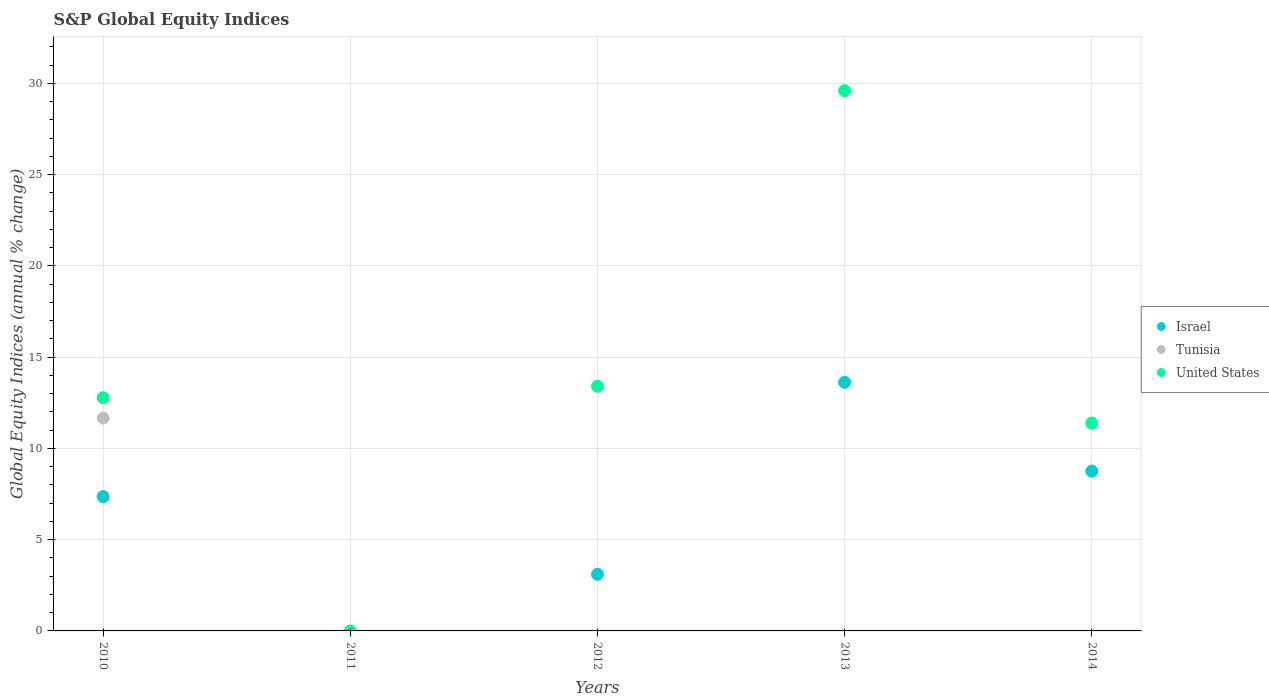How many different coloured dotlines are there?
Provide a succinct answer. 3. Is the number of dotlines equal to the number of legend labels?
Your answer should be very brief. No. Across all years, what is the maximum global equity indices in United States?
Your answer should be compact. 29.6. Across all years, what is the minimum global equity indices in United States?
Your answer should be compact. 0. In which year was the global equity indices in Israel maximum?
Provide a short and direct response. 2013. What is the total global equity indices in United States in the graph?
Make the answer very short. 67.18. What is the difference between the global equity indices in Israel in 2010 and that in 2013?
Offer a terse response. -6.26. What is the difference between the global equity indices in Israel in 2013 and the global equity indices in Tunisia in 2010?
Offer a terse response. 1.96. What is the average global equity indices in United States per year?
Provide a short and direct response. 13.44. In the year 2010, what is the difference between the global equity indices in Israel and global equity indices in United States?
Keep it short and to the point. -5.42. In how many years, is the global equity indices in Israel greater than 6 %?
Offer a terse response. 3. What is the ratio of the global equity indices in United States in 2010 to that in 2013?
Your answer should be compact. 0.43. Is the global equity indices in United States in 2010 less than that in 2012?
Offer a very short reply. Yes. What is the difference between the highest and the second highest global equity indices in Israel?
Make the answer very short. 4.87. What is the difference between the highest and the lowest global equity indices in United States?
Your answer should be compact. 29.6. Is the sum of the global equity indices in United States in 2010 and 2013 greater than the maximum global equity indices in Tunisia across all years?
Provide a short and direct response. Yes. Does the global equity indices in United States monotonically increase over the years?
Ensure brevity in your answer.  No. Is the global equity indices in Tunisia strictly greater than the global equity indices in Israel over the years?
Your response must be concise. No. Is the global equity indices in Israel strictly less than the global equity indices in Tunisia over the years?
Offer a terse response. No. Does the graph contain any zero values?
Make the answer very short. Yes. Does the graph contain grids?
Offer a very short reply. Yes. Where does the legend appear in the graph?
Your answer should be very brief. Center right. How many legend labels are there?
Provide a short and direct response. 3. How are the legend labels stacked?
Offer a terse response. Vertical. What is the title of the graph?
Your answer should be compact. S&P Global Equity Indices. Does "Other small states" appear as one of the legend labels in the graph?
Make the answer very short. No. What is the label or title of the X-axis?
Offer a very short reply. Years. What is the label or title of the Y-axis?
Your response must be concise. Global Equity Indices (annual % change). What is the Global Equity Indices (annual % change) in Israel in 2010?
Your answer should be compact. 7.36. What is the Global Equity Indices (annual % change) of Tunisia in 2010?
Ensure brevity in your answer.  11.66. What is the Global Equity Indices (annual % change) of United States in 2010?
Keep it short and to the point. 12.78. What is the Global Equity Indices (annual % change) in Tunisia in 2011?
Give a very brief answer. 0. What is the Global Equity Indices (annual % change) of United States in 2011?
Keep it short and to the point. 0. What is the Global Equity Indices (annual % change) of Israel in 2012?
Your answer should be compact. 3.1. What is the Global Equity Indices (annual % change) in United States in 2012?
Your response must be concise. 13.41. What is the Global Equity Indices (annual % change) in Israel in 2013?
Your answer should be very brief. 13.62. What is the Global Equity Indices (annual % change) of Tunisia in 2013?
Give a very brief answer. 0. What is the Global Equity Indices (annual % change) in United States in 2013?
Offer a terse response. 29.6. What is the Global Equity Indices (annual % change) of Israel in 2014?
Your answer should be very brief. 8.76. What is the Global Equity Indices (annual % change) in United States in 2014?
Your answer should be very brief. 11.39. Across all years, what is the maximum Global Equity Indices (annual % change) in Israel?
Offer a very short reply. 13.62. Across all years, what is the maximum Global Equity Indices (annual % change) in Tunisia?
Your response must be concise. 11.66. Across all years, what is the maximum Global Equity Indices (annual % change) in United States?
Ensure brevity in your answer.  29.6. Across all years, what is the minimum Global Equity Indices (annual % change) of Israel?
Your response must be concise. 0. What is the total Global Equity Indices (annual % change) of Israel in the graph?
Your answer should be very brief. 32.84. What is the total Global Equity Indices (annual % change) in Tunisia in the graph?
Your answer should be compact. 11.66. What is the total Global Equity Indices (annual % change) of United States in the graph?
Offer a very short reply. 67.18. What is the difference between the Global Equity Indices (annual % change) in Israel in 2010 and that in 2012?
Your answer should be compact. 4.26. What is the difference between the Global Equity Indices (annual % change) in United States in 2010 and that in 2012?
Your response must be concise. -0.62. What is the difference between the Global Equity Indices (annual % change) in Israel in 2010 and that in 2013?
Provide a short and direct response. -6.26. What is the difference between the Global Equity Indices (annual % change) of United States in 2010 and that in 2013?
Provide a short and direct response. -16.82. What is the difference between the Global Equity Indices (annual % change) of Israel in 2010 and that in 2014?
Keep it short and to the point. -1.39. What is the difference between the Global Equity Indices (annual % change) of United States in 2010 and that in 2014?
Your response must be concise. 1.39. What is the difference between the Global Equity Indices (annual % change) in Israel in 2012 and that in 2013?
Your answer should be compact. -10.52. What is the difference between the Global Equity Indices (annual % change) in United States in 2012 and that in 2013?
Your response must be concise. -16.2. What is the difference between the Global Equity Indices (annual % change) in Israel in 2012 and that in 2014?
Make the answer very short. -5.65. What is the difference between the Global Equity Indices (annual % change) in United States in 2012 and that in 2014?
Make the answer very short. 2.02. What is the difference between the Global Equity Indices (annual % change) in Israel in 2013 and that in 2014?
Your response must be concise. 4.87. What is the difference between the Global Equity Indices (annual % change) of United States in 2013 and that in 2014?
Provide a short and direct response. 18.21. What is the difference between the Global Equity Indices (annual % change) in Israel in 2010 and the Global Equity Indices (annual % change) in United States in 2012?
Provide a short and direct response. -6.04. What is the difference between the Global Equity Indices (annual % change) of Tunisia in 2010 and the Global Equity Indices (annual % change) of United States in 2012?
Give a very brief answer. -1.74. What is the difference between the Global Equity Indices (annual % change) in Israel in 2010 and the Global Equity Indices (annual % change) in United States in 2013?
Offer a very short reply. -22.24. What is the difference between the Global Equity Indices (annual % change) in Tunisia in 2010 and the Global Equity Indices (annual % change) in United States in 2013?
Ensure brevity in your answer.  -17.94. What is the difference between the Global Equity Indices (annual % change) in Israel in 2010 and the Global Equity Indices (annual % change) in United States in 2014?
Offer a terse response. -4.03. What is the difference between the Global Equity Indices (annual % change) in Tunisia in 2010 and the Global Equity Indices (annual % change) in United States in 2014?
Your answer should be very brief. 0.27. What is the difference between the Global Equity Indices (annual % change) of Israel in 2012 and the Global Equity Indices (annual % change) of United States in 2013?
Ensure brevity in your answer.  -26.5. What is the difference between the Global Equity Indices (annual % change) in Israel in 2012 and the Global Equity Indices (annual % change) in United States in 2014?
Provide a succinct answer. -8.29. What is the difference between the Global Equity Indices (annual % change) in Israel in 2013 and the Global Equity Indices (annual % change) in United States in 2014?
Your answer should be compact. 2.23. What is the average Global Equity Indices (annual % change) of Israel per year?
Offer a terse response. 6.57. What is the average Global Equity Indices (annual % change) in Tunisia per year?
Offer a terse response. 2.33. What is the average Global Equity Indices (annual % change) in United States per year?
Make the answer very short. 13.44. In the year 2010, what is the difference between the Global Equity Indices (annual % change) of Israel and Global Equity Indices (annual % change) of Tunisia?
Make the answer very short. -4.3. In the year 2010, what is the difference between the Global Equity Indices (annual % change) of Israel and Global Equity Indices (annual % change) of United States?
Provide a short and direct response. -5.42. In the year 2010, what is the difference between the Global Equity Indices (annual % change) of Tunisia and Global Equity Indices (annual % change) of United States?
Keep it short and to the point. -1.12. In the year 2012, what is the difference between the Global Equity Indices (annual % change) of Israel and Global Equity Indices (annual % change) of United States?
Offer a very short reply. -10.3. In the year 2013, what is the difference between the Global Equity Indices (annual % change) of Israel and Global Equity Indices (annual % change) of United States?
Make the answer very short. -15.98. In the year 2014, what is the difference between the Global Equity Indices (annual % change) in Israel and Global Equity Indices (annual % change) in United States?
Provide a short and direct response. -2.64. What is the ratio of the Global Equity Indices (annual % change) in Israel in 2010 to that in 2012?
Your answer should be very brief. 2.37. What is the ratio of the Global Equity Indices (annual % change) in United States in 2010 to that in 2012?
Your answer should be very brief. 0.95. What is the ratio of the Global Equity Indices (annual % change) in Israel in 2010 to that in 2013?
Ensure brevity in your answer.  0.54. What is the ratio of the Global Equity Indices (annual % change) in United States in 2010 to that in 2013?
Give a very brief answer. 0.43. What is the ratio of the Global Equity Indices (annual % change) of Israel in 2010 to that in 2014?
Your response must be concise. 0.84. What is the ratio of the Global Equity Indices (annual % change) in United States in 2010 to that in 2014?
Provide a short and direct response. 1.12. What is the ratio of the Global Equity Indices (annual % change) of Israel in 2012 to that in 2013?
Provide a short and direct response. 0.23. What is the ratio of the Global Equity Indices (annual % change) of United States in 2012 to that in 2013?
Ensure brevity in your answer.  0.45. What is the ratio of the Global Equity Indices (annual % change) in Israel in 2012 to that in 2014?
Provide a succinct answer. 0.35. What is the ratio of the Global Equity Indices (annual % change) of United States in 2012 to that in 2014?
Provide a succinct answer. 1.18. What is the ratio of the Global Equity Indices (annual % change) in Israel in 2013 to that in 2014?
Make the answer very short. 1.56. What is the ratio of the Global Equity Indices (annual % change) of United States in 2013 to that in 2014?
Keep it short and to the point. 2.6. What is the difference between the highest and the second highest Global Equity Indices (annual % change) in Israel?
Provide a short and direct response. 4.87. What is the difference between the highest and the second highest Global Equity Indices (annual % change) of United States?
Give a very brief answer. 16.2. What is the difference between the highest and the lowest Global Equity Indices (annual % change) of Israel?
Your answer should be compact. 13.62. What is the difference between the highest and the lowest Global Equity Indices (annual % change) in Tunisia?
Your answer should be compact. 11.66. What is the difference between the highest and the lowest Global Equity Indices (annual % change) of United States?
Ensure brevity in your answer.  29.6. 